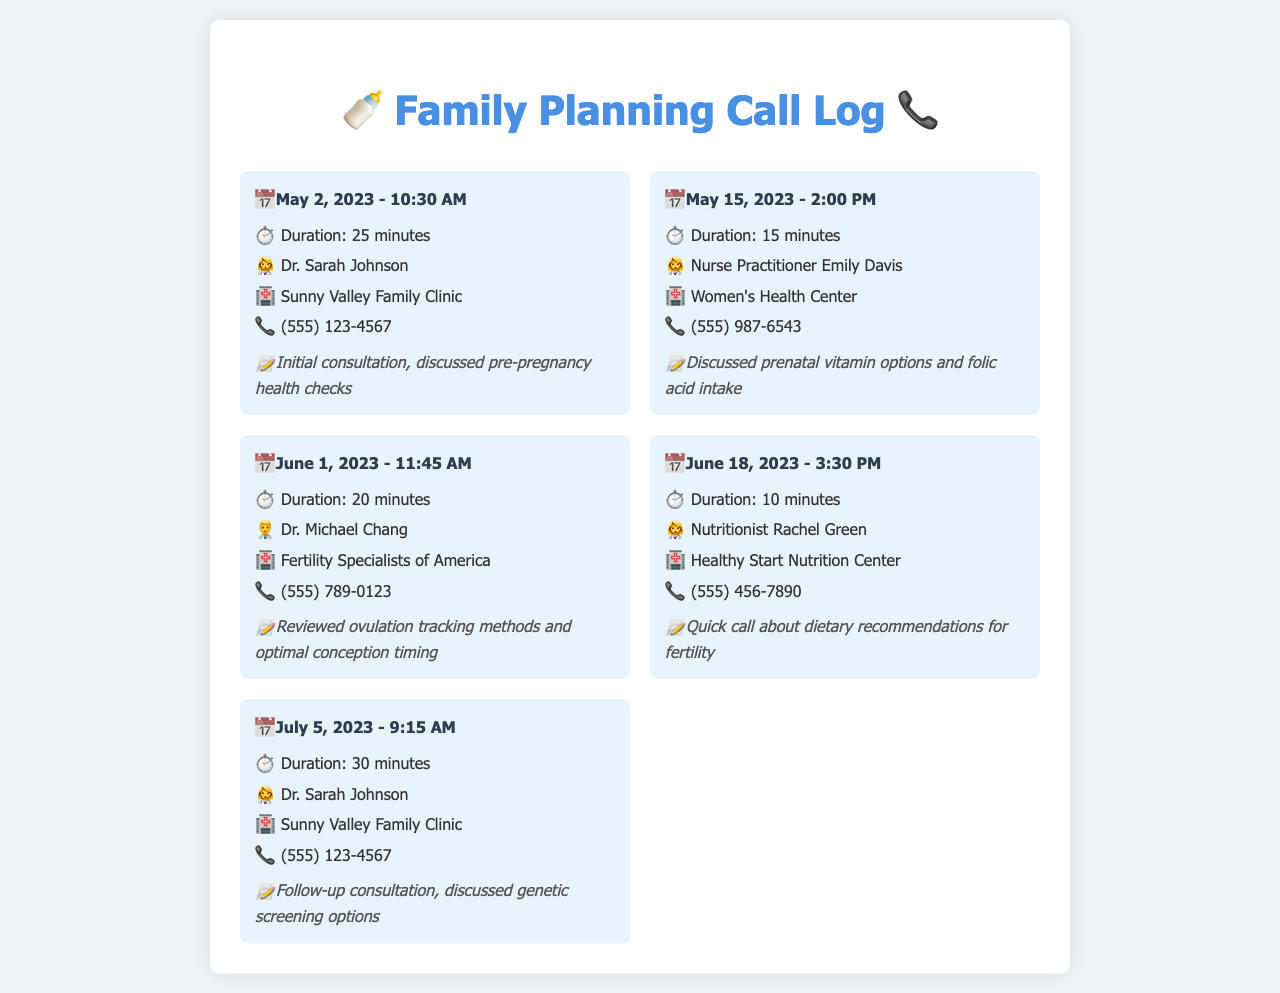What was the duration of the call on May 2, 2023? The duration of the call on May 2, 2023, is explicitly stated in the document.
Answer: 25 minutes Who did the couple speak to on June 1, 2023? The name of the healthcare provider for the call on June 1, 2023, is mentioned in the document.
Answer: Dr. Michael Chang What were the topics discussed during the call with Nurse Practitioner Emily Davis? The notes for the call provide information about what was discussed.
Answer: Prenatal vitamin options and folic acid intake What is the contact number for Sunny Valley Family Clinic? The document lists the contact number for this clinic under the corresponding call entry.
Answer: (555) 123-4567 How many minutes was the shortest call? The question requires comparing the duration of all calls to determine the shortest one.
Answer: 10 minutes Who provided dietary recommendations for fertility? The document specifies which professional offered dietary recommendations.
Answer: Nutritionist Rachel Green What date was the follow-up consultation held? The date of the follow-up consultation can be found in the document.
Answer: July 5, 2023 Which clinic did they contact for the initial consultation? The name of the clinic for the initial consultation is provided in the call entry.
Answer: Sunny Valley Family Clinic How many total calls are listed in the log? The document presents each call entry, allowing for a count of all listed calls.
Answer: 5 calls 